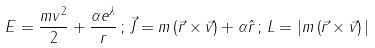<formula> <loc_0><loc_0><loc_500><loc_500>E = \frac { m v ^ { 2 } } { 2 } + \frac { \alpha e ^ { \lambda } } { r } \, ; \, \vec { J } = m \left ( \vec { r } \times \vec { v } \right ) + \alpha \hat { r } \, ; \, L = | m \left ( \vec { r } \times \vec { v } \right ) |</formula> 